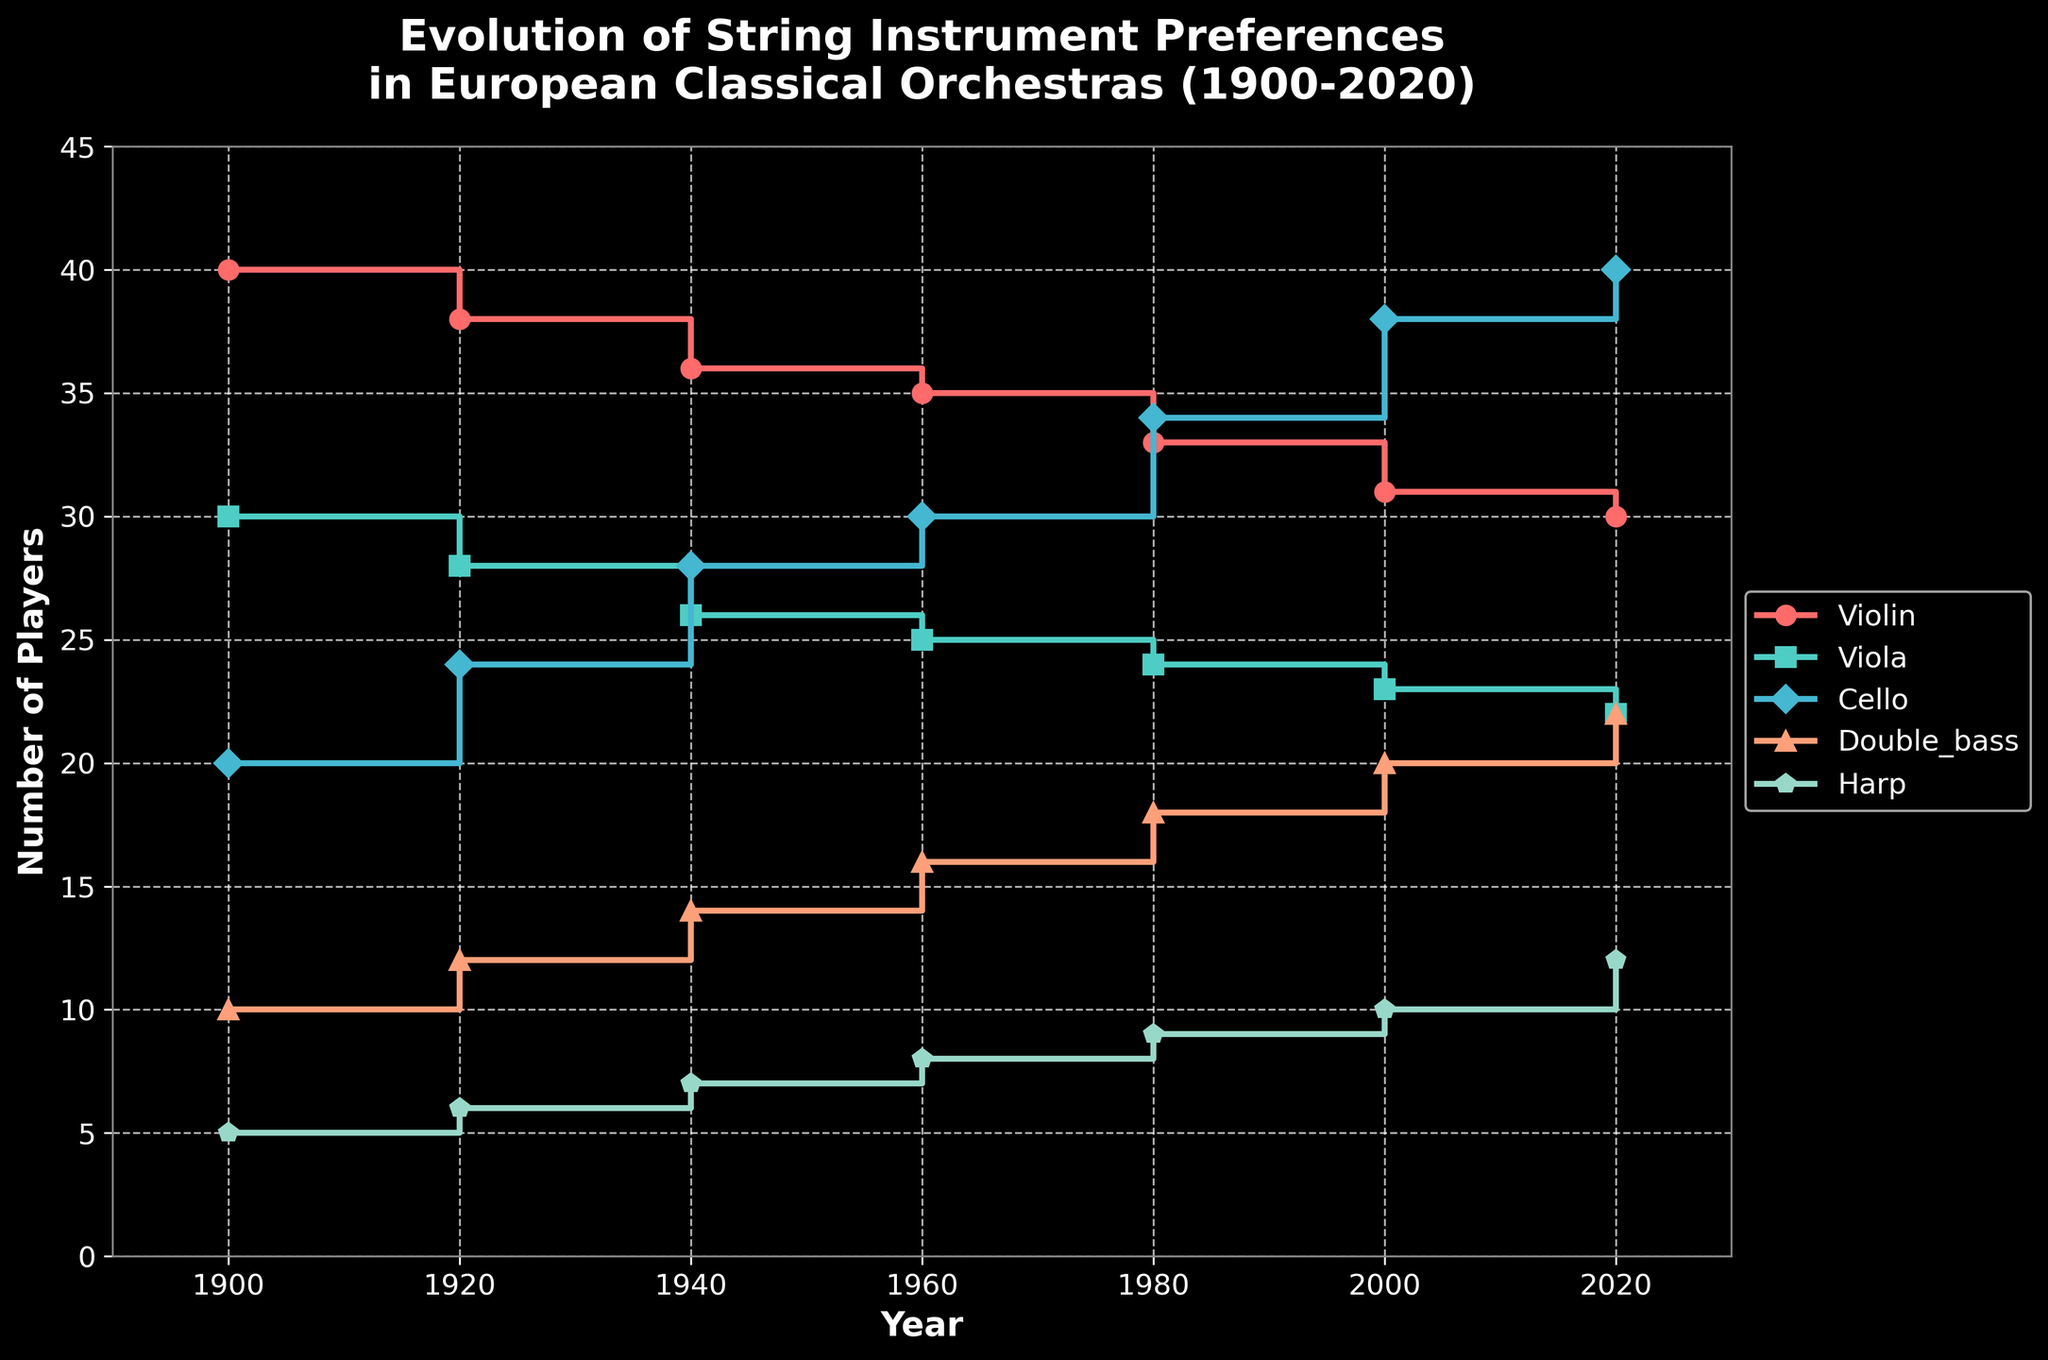What is the title of the figure? The title can be found at the top of the figure. It reads "Evolution of String Instrument Preferences in European Classical Orchestras (1900-2020)".
Answer: Evolution of String Instrument Preferences in European Classical Orchestras (1900-2020) What is the trend for cello players from 1900 to 2020? By examining the plot, you'll observe that the number of cello players rises steadily from 20 in 1900 to 40 in 2020.
Answer: Increasing How many violin players were there in 1980? Look at the data point for the violin in the year 1980, which is indicated as 33 players.
Answer: 33 Which instrument had the highest increase in the number of players from 1900 to 2020? To answer this, you need to compare the difference in player counts for each instrument from 1900 to 2020. Cello increased from 20 to 40, which is the largest increase of +20 players.
Answer: Cello What is the average number of harp players between 1900 and 2020? Sum the number of harp players in each year (5, 6, 7, 8, 9, 10, 12) and divide by the number of years (7). (5 + 6 + 7 + 8 + 9 + 10 + 12) / 7 = 57 / 7 = 8.14
Answer: 8.14 Which two instruments have the closest number of players in 2020? In 2020, look at the data points for all instruments. Violin has 30, Viola has 22, Cello has 40, Double Bass has 22, and Harp has 12. Between Viola and Double Bass, both have 22 players, which are the closest.
Answer: Viola and Double Bass How does the popularity of the double bass trend from 1900 to 2020? Examine the plot line of double bass. The number increases steadily from 10 in 1900 to 22 in 2020.
Answer: Increasing What is the total number of players for all instruments combined in 2020? Add up the number of players for each instrument in 2020: 30 (violin) + 22 (viola) + 40 (cello) + 22 (double bass) + 12 (harp) = 126.
Answer: 126 Which instrument saw the least change in the number of players from 1900 to 2020? Looking at the data points, the violin decreased from 40 to 30, a change of -10 players, which is the smallest change compared to other instruments.
Answer: Violin 